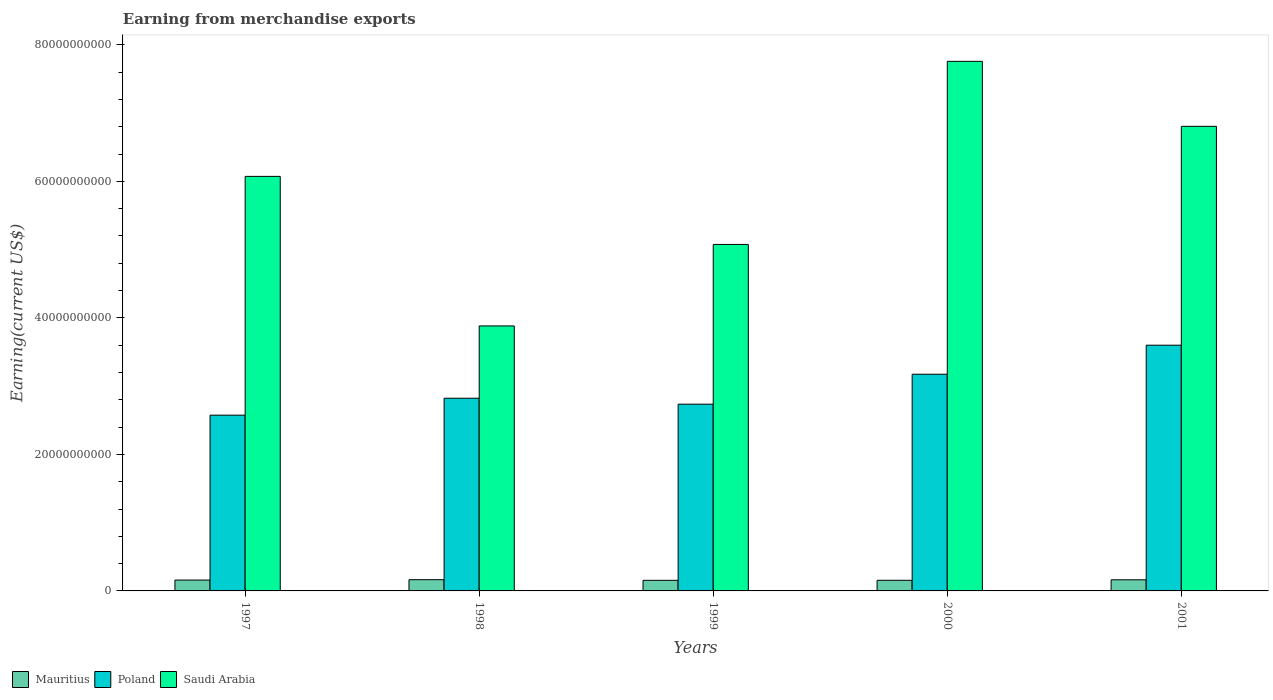How many different coloured bars are there?
Offer a very short reply. 3. How many groups of bars are there?
Your response must be concise. 5. How many bars are there on the 3rd tick from the right?
Your answer should be compact. 3. In how many cases, is the number of bars for a given year not equal to the number of legend labels?
Make the answer very short. 0. What is the amount earned from merchandise exports in Saudi Arabia in 1997?
Your answer should be very brief. 6.07e+1. Across all years, what is the maximum amount earned from merchandise exports in Saudi Arabia?
Your answer should be very brief. 7.76e+1. Across all years, what is the minimum amount earned from merchandise exports in Saudi Arabia?
Make the answer very short. 3.88e+1. In which year was the amount earned from merchandise exports in Poland minimum?
Offer a terse response. 1997. What is the total amount earned from merchandise exports in Mauritius in the graph?
Offer a very short reply. 7.98e+09. What is the difference between the amount earned from merchandise exports in Poland in 2000 and that in 2001?
Provide a succinct answer. -4.25e+09. What is the difference between the amount earned from merchandise exports in Saudi Arabia in 2001 and the amount earned from merchandise exports in Mauritius in 1999?
Give a very brief answer. 6.65e+1. What is the average amount earned from merchandise exports in Saudi Arabia per year?
Keep it short and to the point. 5.92e+1. In the year 2000, what is the difference between the amount earned from merchandise exports in Poland and amount earned from merchandise exports in Saudi Arabia?
Your answer should be very brief. -4.58e+1. What is the ratio of the amount earned from merchandise exports in Mauritius in 1999 to that in 2001?
Give a very brief answer. 0.95. What is the difference between the highest and the second highest amount earned from merchandise exports in Mauritius?
Your answer should be very brief. 1.72e+07. What is the difference between the highest and the lowest amount earned from merchandise exports in Poland?
Offer a very short reply. 1.02e+1. Is the sum of the amount earned from merchandise exports in Saudi Arabia in 1999 and 2001 greater than the maximum amount earned from merchandise exports in Poland across all years?
Offer a terse response. Yes. What does the 3rd bar from the left in 2000 represents?
Make the answer very short. Saudi Arabia. What does the 2nd bar from the right in 2000 represents?
Your answer should be very brief. Poland. Is it the case that in every year, the sum of the amount earned from merchandise exports in Poland and amount earned from merchandise exports in Saudi Arabia is greater than the amount earned from merchandise exports in Mauritius?
Offer a terse response. Yes. Are all the bars in the graph horizontal?
Keep it short and to the point. No. How many years are there in the graph?
Ensure brevity in your answer.  5. What is the difference between two consecutive major ticks on the Y-axis?
Your response must be concise. 2.00e+1. Does the graph contain any zero values?
Your answer should be very brief. No. Where does the legend appear in the graph?
Offer a very short reply. Bottom left. How are the legend labels stacked?
Offer a very short reply. Horizontal. What is the title of the graph?
Ensure brevity in your answer.  Earning from merchandise exports. Does "Niger" appear as one of the legend labels in the graph?
Your answer should be very brief. No. What is the label or title of the X-axis?
Your response must be concise. Years. What is the label or title of the Y-axis?
Provide a short and direct response. Earning(current US$). What is the Earning(current US$) of Mauritius in 1997?
Offer a terse response. 1.59e+09. What is the Earning(current US$) of Poland in 1997?
Your answer should be compact. 2.58e+1. What is the Earning(current US$) in Saudi Arabia in 1997?
Offer a terse response. 6.07e+1. What is the Earning(current US$) in Mauritius in 1998?
Your response must be concise. 1.64e+09. What is the Earning(current US$) of Poland in 1998?
Keep it short and to the point. 2.82e+1. What is the Earning(current US$) of Saudi Arabia in 1998?
Provide a succinct answer. 3.88e+1. What is the Earning(current US$) in Mauritius in 1999?
Provide a short and direct response. 1.55e+09. What is the Earning(current US$) in Poland in 1999?
Keep it short and to the point. 2.74e+1. What is the Earning(current US$) in Saudi Arabia in 1999?
Offer a terse response. 5.08e+1. What is the Earning(current US$) of Mauritius in 2000?
Give a very brief answer. 1.56e+09. What is the Earning(current US$) in Poland in 2000?
Ensure brevity in your answer.  3.17e+1. What is the Earning(current US$) in Saudi Arabia in 2000?
Offer a very short reply. 7.76e+1. What is the Earning(current US$) in Mauritius in 2001?
Provide a short and direct response. 1.63e+09. What is the Earning(current US$) of Poland in 2001?
Provide a short and direct response. 3.60e+1. What is the Earning(current US$) of Saudi Arabia in 2001?
Offer a terse response. 6.81e+1. Across all years, what is the maximum Earning(current US$) of Mauritius?
Keep it short and to the point. 1.64e+09. Across all years, what is the maximum Earning(current US$) of Poland?
Provide a short and direct response. 3.60e+1. Across all years, what is the maximum Earning(current US$) in Saudi Arabia?
Offer a very short reply. 7.76e+1. Across all years, what is the minimum Earning(current US$) in Mauritius?
Your answer should be very brief. 1.55e+09. Across all years, what is the minimum Earning(current US$) of Poland?
Make the answer very short. 2.58e+1. Across all years, what is the minimum Earning(current US$) of Saudi Arabia?
Provide a short and direct response. 3.88e+1. What is the total Earning(current US$) in Mauritius in the graph?
Offer a terse response. 7.98e+09. What is the total Earning(current US$) in Poland in the graph?
Make the answer very short. 1.49e+11. What is the total Earning(current US$) in Saudi Arabia in the graph?
Keep it short and to the point. 2.96e+11. What is the difference between the Earning(current US$) in Mauritius in 1997 and that in 1998?
Provide a short and direct response. -5.30e+07. What is the difference between the Earning(current US$) in Poland in 1997 and that in 1998?
Offer a very short reply. -2.48e+09. What is the difference between the Earning(current US$) in Saudi Arabia in 1997 and that in 1998?
Offer a terse response. 2.19e+1. What is the difference between the Earning(current US$) in Mauritius in 1997 and that in 1999?
Keep it short and to the point. 3.80e+07. What is the difference between the Earning(current US$) in Poland in 1997 and that in 1999?
Give a very brief answer. -1.61e+09. What is the difference between the Earning(current US$) of Saudi Arabia in 1997 and that in 1999?
Offer a terse response. 9.97e+09. What is the difference between the Earning(current US$) in Mauritius in 1997 and that in 2000?
Provide a succinct answer. 3.50e+07. What is the difference between the Earning(current US$) in Poland in 1997 and that in 2000?
Provide a short and direct response. -6.00e+09. What is the difference between the Earning(current US$) of Saudi Arabia in 1997 and that in 2000?
Keep it short and to the point. -1.69e+1. What is the difference between the Earning(current US$) of Mauritius in 1997 and that in 2001?
Offer a terse response. -3.58e+07. What is the difference between the Earning(current US$) in Poland in 1997 and that in 2001?
Provide a short and direct response. -1.02e+1. What is the difference between the Earning(current US$) of Saudi Arabia in 1997 and that in 2001?
Your answer should be compact. -7.33e+09. What is the difference between the Earning(current US$) of Mauritius in 1998 and that in 1999?
Make the answer very short. 9.10e+07. What is the difference between the Earning(current US$) in Poland in 1998 and that in 1999?
Provide a short and direct response. 8.71e+08. What is the difference between the Earning(current US$) of Saudi Arabia in 1998 and that in 1999?
Ensure brevity in your answer.  -1.19e+1. What is the difference between the Earning(current US$) of Mauritius in 1998 and that in 2000?
Give a very brief answer. 8.80e+07. What is the difference between the Earning(current US$) of Poland in 1998 and that in 2000?
Offer a terse response. -3.52e+09. What is the difference between the Earning(current US$) of Saudi Arabia in 1998 and that in 2000?
Your answer should be compact. -3.88e+1. What is the difference between the Earning(current US$) in Mauritius in 1998 and that in 2001?
Offer a terse response. 1.72e+07. What is the difference between the Earning(current US$) of Poland in 1998 and that in 2001?
Offer a terse response. -7.77e+09. What is the difference between the Earning(current US$) in Saudi Arabia in 1998 and that in 2001?
Offer a terse response. -2.92e+1. What is the difference between the Earning(current US$) of Poland in 1999 and that in 2000?
Your answer should be compact. -4.39e+09. What is the difference between the Earning(current US$) of Saudi Arabia in 1999 and that in 2000?
Keep it short and to the point. -2.68e+1. What is the difference between the Earning(current US$) in Mauritius in 1999 and that in 2001?
Your response must be concise. -7.38e+07. What is the difference between the Earning(current US$) in Poland in 1999 and that in 2001?
Make the answer very short. -8.64e+09. What is the difference between the Earning(current US$) of Saudi Arabia in 1999 and that in 2001?
Your answer should be compact. -1.73e+1. What is the difference between the Earning(current US$) in Mauritius in 2000 and that in 2001?
Your answer should be compact. -7.08e+07. What is the difference between the Earning(current US$) of Poland in 2000 and that in 2001?
Offer a terse response. -4.25e+09. What is the difference between the Earning(current US$) of Saudi Arabia in 2000 and that in 2001?
Provide a succinct answer. 9.52e+09. What is the difference between the Earning(current US$) in Mauritius in 1997 and the Earning(current US$) in Poland in 1998?
Give a very brief answer. -2.66e+1. What is the difference between the Earning(current US$) in Mauritius in 1997 and the Earning(current US$) in Saudi Arabia in 1998?
Offer a terse response. -3.72e+1. What is the difference between the Earning(current US$) of Poland in 1997 and the Earning(current US$) of Saudi Arabia in 1998?
Your answer should be very brief. -1.31e+1. What is the difference between the Earning(current US$) of Mauritius in 1997 and the Earning(current US$) of Poland in 1999?
Your answer should be very brief. -2.58e+1. What is the difference between the Earning(current US$) of Mauritius in 1997 and the Earning(current US$) of Saudi Arabia in 1999?
Your response must be concise. -4.92e+1. What is the difference between the Earning(current US$) in Poland in 1997 and the Earning(current US$) in Saudi Arabia in 1999?
Your response must be concise. -2.50e+1. What is the difference between the Earning(current US$) of Mauritius in 1997 and the Earning(current US$) of Poland in 2000?
Offer a terse response. -3.02e+1. What is the difference between the Earning(current US$) in Mauritius in 1997 and the Earning(current US$) in Saudi Arabia in 2000?
Provide a succinct answer. -7.60e+1. What is the difference between the Earning(current US$) in Poland in 1997 and the Earning(current US$) in Saudi Arabia in 2000?
Keep it short and to the point. -5.18e+1. What is the difference between the Earning(current US$) of Mauritius in 1997 and the Earning(current US$) of Poland in 2001?
Offer a very short reply. -3.44e+1. What is the difference between the Earning(current US$) of Mauritius in 1997 and the Earning(current US$) of Saudi Arabia in 2001?
Keep it short and to the point. -6.65e+1. What is the difference between the Earning(current US$) in Poland in 1997 and the Earning(current US$) in Saudi Arabia in 2001?
Provide a succinct answer. -4.23e+1. What is the difference between the Earning(current US$) in Mauritius in 1998 and the Earning(current US$) in Poland in 1999?
Make the answer very short. -2.57e+1. What is the difference between the Earning(current US$) of Mauritius in 1998 and the Earning(current US$) of Saudi Arabia in 1999?
Your answer should be compact. -4.91e+1. What is the difference between the Earning(current US$) in Poland in 1998 and the Earning(current US$) in Saudi Arabia in 1999?
Your answer should be compact. -2.25e+1. What is the difference between the Earning(current US$) of Mauritius in 1998 and the Earning(current US$) of Poland in 2000?
Provide a short and direct response. -3.01e+1. What is the difference between the Earning(current US$) in Mauritius in 1998 and the Earning(current US$) in Saudi Arabia in 2000?
Make the answer very short. -7.59e+1. What is the difference between the Earning(current US$) of Poland in 1998 and the Earning(current US$) of Saudi Arabia in 2000?
Offer a very short reply. -4.94e+1. What is the difference between the Earning(current US$) in Mauritius in 1998 and the Earning(current US$) in Poland in 2001?
Make the answer very short. -3.44e+1. What is the difference between the Earning(current US$) in Mauritius in 1998 and the Earning(current US$) in Saudi Arabia in 2001?
Keep it short and to the point. -6.64e+1. What is the difference between the Earning(current US$) of Poland in 1998 and the Earning(current US$) of Saudi Arabia in 2001?
Your answer should be compact. -3.98e+1. What is the difference between the Earning(current US$) of Mauritius in 1999 and the Earning(current US$) of Poland in 2000?
Give a very brief answer. -3.02e+1. What is the difference between the Earning(current US$) in Mauritius in 1999 and the Earning(current US$) in Saudi Arabia in 2000?
Make the answer very short. -7.60e+1. What is the difference between the Earning(current US$) in Poland in 1999 and the Earning(current US$) in Saudi Arabia in 2000?
Your response must be concise. -5.02e+1. What is the difference between the Earning(current US$) of Mauritius in 1999 and the Earning(current US$) of Poland in 2001?
Give a very brief answer. -3.44e+1. What is the difference between the Earning(current US$) of Mauritius in 1999 and the Earning(current US$) of Saudi Arabia in 2001?
Give a very brief answer. -6.65e+1. What is the difference between the Earning(current US$) in Poland in 1999 and the Earning(current US$) in Saudi Arabia in 2001?
Your answer should be very brief. -4.07e+1. What is the difference between the Earning(current US$) of Mauritius in 2000 and the Earning(current US$) of Poland in 2001?
Make the answer very short. -3.44e+1. What is the difference between the Earning(current US$) of Mauritius in 2000 and the Earning(current US$) of Saudi Arabia in 2001?
Provide a succinct answer. -6.65e+1. What is the difference between the Earning(current US$) in Poland in 2000 and the Earning(current US$) in Saudi Arabia in 2001?
Offer a very short reply. -3.63e+1. What is the average Earning(current US$) in Mauritius per year?
Offer a terse response. 1.60e+09. What is the average Earning(current US$) of Poland per year?
Provide a succinct answer. 2.98e+1. What is the average Earning(current US$) of Saudi Arabia per year?
Offer a very short reply. 5.92e+1. In the year 1997, what is the difference between the Earning(current US$) in Mauritius and Earning(current US$) in Poland?
Offer a terse response. -2.42e+1. In the year 1997, what is the difference between the Earning(current US$) of Mauritius and Earning(current US$) of Saudi Arabia?
Provide a succinct answer. -5.91e+1. In the year 1997, what is the difference between the Earning(current US$) of Poland and Earning(current US$) of Saudi Arabia?
Your answer should be very brief. -3.50e+1. In the year 1998, what is the difference between the Earning(current US$) of Mauritius and Earning(current US$) of Poland?
Give a very brief answer. -2.66e+1. In the year 1998, what is the difference between the Earning(current US$) in Mauritius and Earning(current US$) in Saudi Arabia?
Give a very brief answer. -3.72e+1. In the year 1998, what is the difference between the Earning(current US$) in Poland and Earning(current US$) in Saudi Arabia?
Make the answer very short. -1.06e+1. In the year 1999, what is the difference between the Earning(current US$) in Mauritius and Earning(current US$) in Poland?
Your answer should be compact. -2.58e+1. In the year 1999, what is the difference between the Earning(current US$) of Mauritius and Earning(current US$) of Saudi Arabia?
Your answer should be compact. -4.92e+1. In the year 1999, what is the difference between the Earning(current US$) in Poland and Earning(current US$) in Saudi Arabia?
Make the answer very short. -2.34e+1. In the year 2000, what is the difference between the Earning(current US$) in Mauritius and Earning(current US$) in Poland?
Provide a succinct answer. -3.02e+1. In the year 2000, what is the difference between the Earning(current US$) of Mauritius and Earning(current US$) of Saudi Arabia?
Provide a succinct answer. -7.60e+1. In the year 2000, what is the difference between the Earning(current US$) in Poland and Earning(current US$) in Saudi Arabia?
Your answer should be compact. -4.58e+1. In the year 2001, what is the difference between the Earning(current US$) of Mauritius and Earning(current US$) of Poland?
Provide a succinct answer. -3.44e+1. In the year 2001, what is the difference between the Earning(current US$) in Mauritius and Earning(current US$) in Saudi Arabia?
Your answer should be very brief. -6.64e+1. In the year 2001, what is the difference between the Earning(current US$) of Poland and Earning(current US$) of Saudi Arabia?
Your answer should be compact. -3.21e+1. What is the ratio of the Earning(current US$) of Mauritius in 1997 to that in 1998?
Your response must be concise. 0.97. What is the ratio of the Earning(current US$) of Poland in 1997 to that in 1998?
Your answer should be compact. 0.91. What is the ratio of the Earning(current US$) of Saudi Arabia in 1997 to that in 1998?
Your answer should be compact. 1.56. What is the ratio of the Earning(current US$) in Mauritius in 1997 to that in 1999?
Provide a succinct answer. 1.02. What is the ratio of the Earning(current US$) of Saudi Arabia in 1997 to that in 1999?
Provide a succinct answer. 1.2. What is the ratio of the Earning(current US$) in Mauritius in 1997 to that in 2000?
Give a very brief answer. 1.02. What is the ratio of the Earning(current US$) in Poland in 1997 to that in 2000?
Your answer should be compact. 0.81. What is the ratio of the Earning(current US$) of Saudi Arabia in 1997 to that in 2000?
Offer a very short reply. 0.78. What is the ratio of the Earning(current US$) of Mauritius in 1997 to that in 2001?
Your answer should be very brief. 0.98. What is the ratio of the Earning(current US$) in Poland in 1997 to that in 2001?
Offer a very short reply. 0.72. What is the ratio of the Earning(current US$) of Saudi Arabia in 1997 to that in 2001?
Your answer should be compact. 0.89. What is the ratio of the Earning(current US$) of Mauritius in 1998 to that in 1999?
Provide a succinct answer. 1.06. What is the ratio of the Earning(current US$) in Poland in 1998 to that in 1999?
Provide a short and direct response. 1.03. What is the ratio of the Earning(current US$) in Saudi Arabia in 1998 to that in 1999?
Provide a short and direct response. 0.76. What is the ratio of the Earning(current US$) in Mauritius in 1998 to that in 2000?
Provide a succinct answer. 1.06. What is the ratio of the Earning(current US$) in Poland in 1998 to that in 2000?
Provide a short and direct response. 0.89. What is the ratio of the Earning(current US$) of Saudi Arabia in 1998 to that in 2000?
Keep it short and to the point. 0.5. What is the ratio of the Earning(current US$) of Mauritius in 1998 to that in 2001?
Your answer should be compact. 1.01. What is the ratio of the Earning(current US$) in Poland in 1998 to that in 2001?
Give a very brief answer. 0.78. What is the ratio of the Earning(current US$) of Saudi Arabia in 1998 to that in 2001?
Ensure brevity in your answer.  0.57. What is the ratio of the Earning(current US$) in Mauritius in 1999 to that in 2000?
Provide a succinct answer. 1. What is the ratio of the Earning(current US$) in Poland in 1999 to that in 2000?
Offer a very short reply. 0.86. What is the ratio of the Earning(current US$) in Saudi Arabia in 1999 to that in 2000?
Provide a succinct answer. 0.65. What is the ratio of the Earning(current US$) in Mauritius in 1999 to that in 2001?
Give a very brief answer. 0.95. What is the ratio of the Earning(current US$) of Poland in 1999 to that in 2001?
Your answer should be very brief. 0.76. What is the ratio of the Earning(current US$) of Saudi Arabia in 1999 to that in 2001?
Provide a succinct answer. 0.75. What is the ratio of the Earning(current US$) of Mauritius in 2000 to that in 2001?
Your answer should be compact. 0.96. What is the ratio of the Earning(current US$) of Poland in 2000 to that in 2001?
Provide a short and direct response. 0.88. What is the ratio of the Earning(current US$) of Saudi Arabia in 2000 to that in 2001?
Keep it short and to the point. 1.14. What is the difference between the highest and the second highest Earning(current US$) of Mauritius?
Ensure brevity in your answer.  1.72e+07. What is the difference between the highest and the second highest Earning(current US$) of Poland?
Make the answer very short. 4.25e+09. What is the difference between the highest and the second highest Earning(current US$) in Saudi Arabia?
Your response must be concise. 9.52e+09. What is the difference between the highest and the lowest Earning(current US$) in Mauritius?
Offer a terse response. 9.10e+07. What is the difference between the highest and the lowest Earning(current US$) of Poland?
Offer a very short reply. 1.02e+1. What is the difference between the highest and the lowest Earning(current US$) of Saudi Arabia?
Your response must be concise. 3.88e+1. 